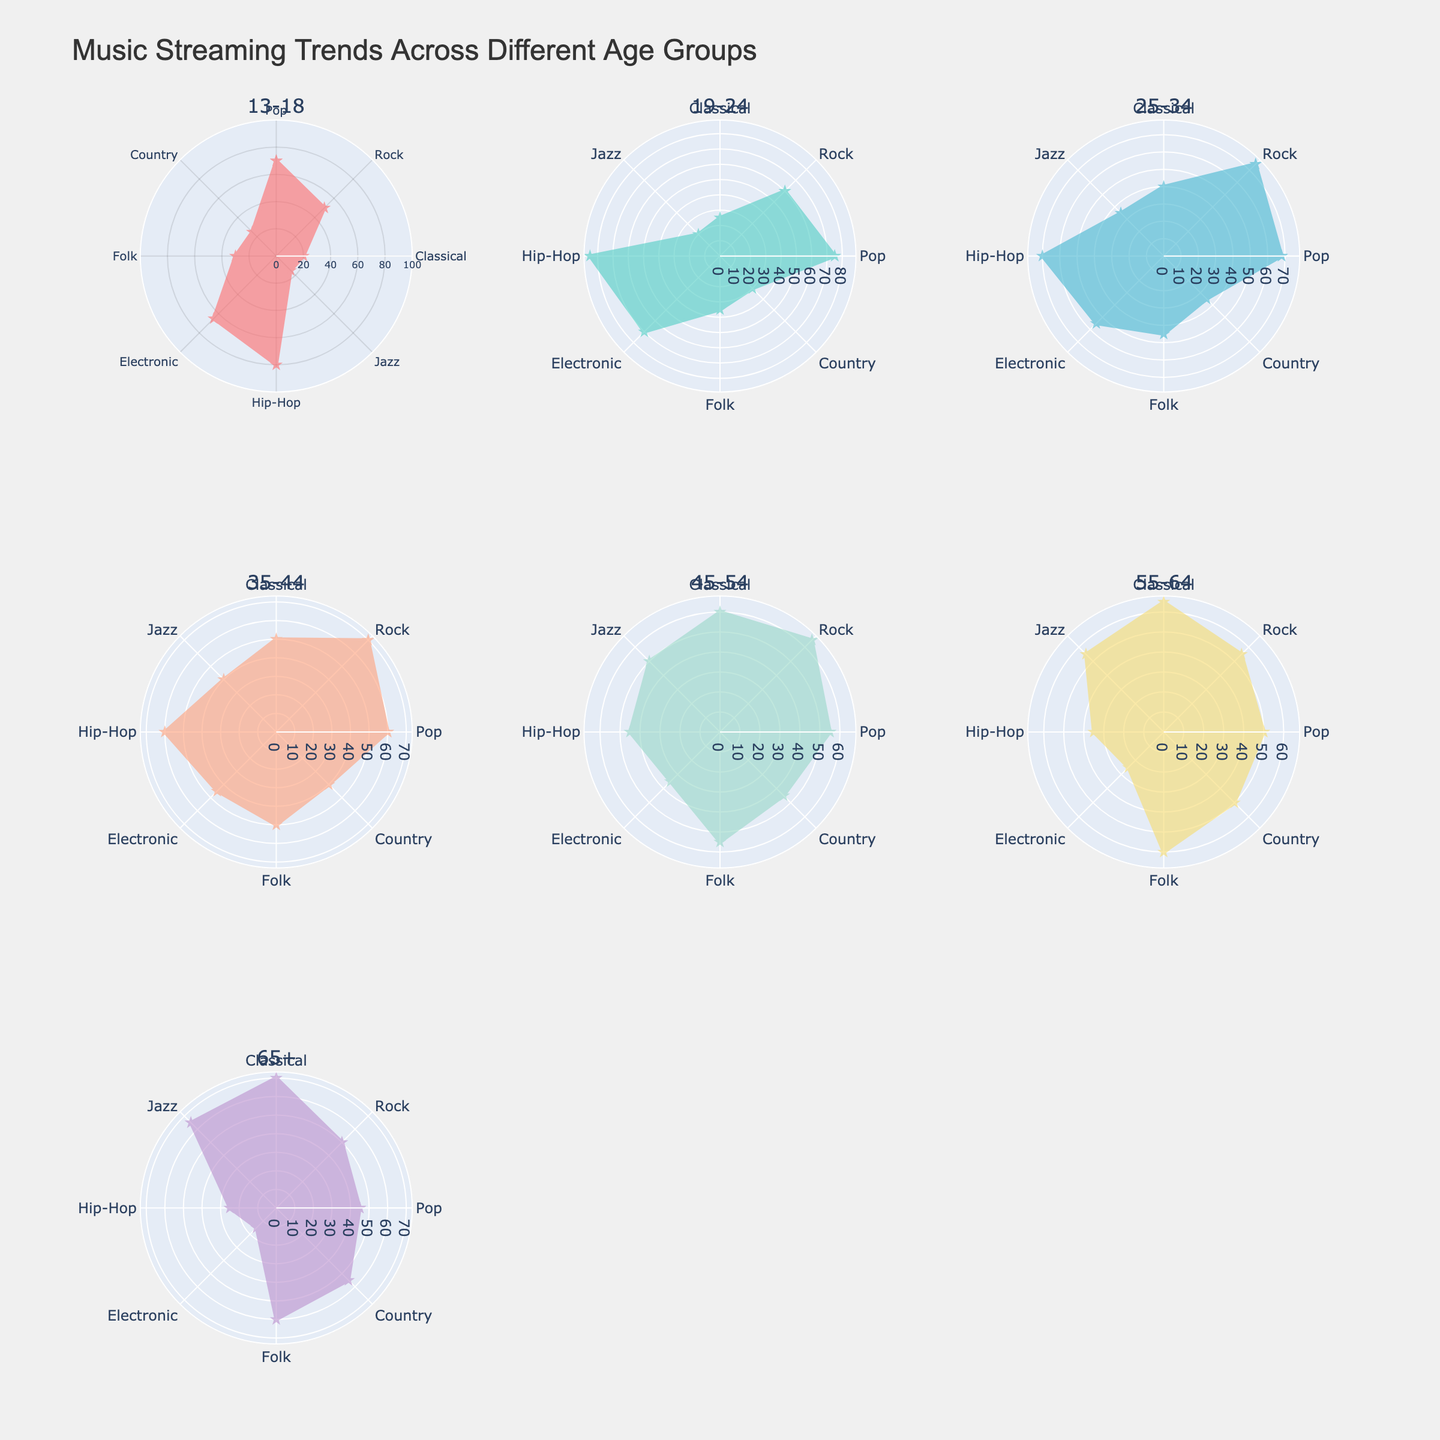How many age groups are represented in the figure? The subplot titles correspond to each age group. Counting the number of subplot titles gives the number of age groups.
Answer: 7 Which age group has the highest interest in Electronic music? By comparing the values for Electronic music across all age groups, the one with the highest value is identified.
Answer: 19-24 What is the least popular genre among the 65+ age group? From the radar chart of the 65+ age group, we identify the genre with the smallest value.
Answer: Hip-Hop Compare the popularity of Classical music between the 25-34 and 55-64 age groups. Which group prefers it more? Look at the values for Classical music in the 25-34 and 55-64 age groups and compare them to determine which is higher.
Answer: 55-64 What's the total interest in Rock music across all age groups? Sum the values for Rock music from all age groups: (50 + 60 + 75 + 70 + 65 + 55 + 50).
Answer: 425 Which age group has the most balanced interest across all genres? Identify the subplot where the lengths of the radar chart's axes are the most uniform, indicating balanced interest.
Answer: 65+ Out of Pop and Hip-Hop, which genre do people aged 35-44 prefer more? Compare the values for Pop and Hip-Hop within the 35-44 age group to see which is higher.
Answer: Pop Is Jazz more popular among the 45-54 or 65+ age group? Compare the Jazz values for the 45-54 and 65+ age groups and identify which is higher.
Answer: 65+ What is the average interest value across all genres for the 13-18 age group? Calculate the average by summing the values for all genres in the 13-18 age group and dividing by the number of genres: (70 + 50 + 20 + 15 + 80 + 65 + 30 + 25) / 8.
Answer: 44.375 Which genre shows the largest decline in popularity from the 19-24 to the 65+ age group? Calculate the difference in values for each genre between the 19-24 and 65+ age groups and identify the one with the largest decline.
Answer: Hip-Hop 